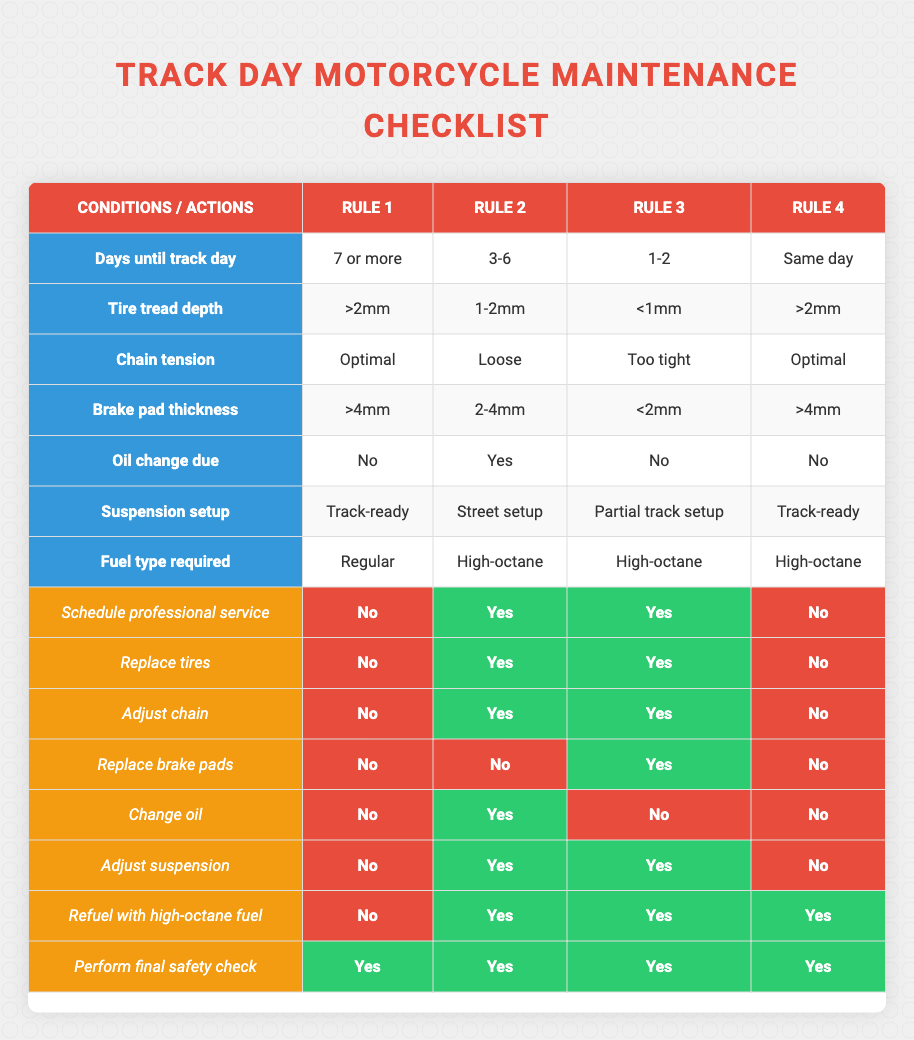What actions should be taken if there are 7 or more days until the track day? Based on the table, with 7 or more days until the track day, all actions are marked as 'No' except for 'Perform final safety check', which is marked as 'Yes'. Therefore, no professional service, tire replacement, chain adjustment, brake pad replacement, oil change, suspension adjustment, or refueling with high-octane fuel is necessary.
Answer: Perform final safety check Is it necessary to adjust the chain if the tire tread depth is between 1-2mm? The table indicates that if the tire tread depth is between 1-2mm and there are 3-6 days until the track day, the action 'Adjust chain' is marked as 'Yes', so it is necessary.
Answer: Yes What is the required fuel type if the oil change is due? According to the table, if the oil change is due and the conditions fall within the 3-6 days category, the fuel type required is 'High-octane'.
Answer: High-octane If the chain tension is optimal, how does that affect tire replacement when there are 1-2 days left until the track day? Looking at the conditions for 1-2 days left until the track day and with optimal chain tension, the table still requires 'Replace tires' to be marked as 'Yes', meaning tire replacement is necessary regardless of the chain tension being optimal.
Answer: Yes, tire replacement is necessary What actions should you take if the brake pad thickness is less than 2mm? The table shows that if the brake pad thickness is less than 2mm, which applies for the 1-2 days left until the track day, all actions involved require 'Yes', indicating that professional service should be scheduled, tires should be replaced, chains should be adjusted, and brake pads should also be replaced.
Answer: Schedule professional service, replace tires, adjust chain, replace brake pads Is a professional service required if the suspension setup is on a street setup with less than a week until the track day? The conditions for this case show that with a street setup and 3-6 days until the track day, 'Schedule professional service' is marked as 'Yes', thus making it necessary.
Answer: Yes 